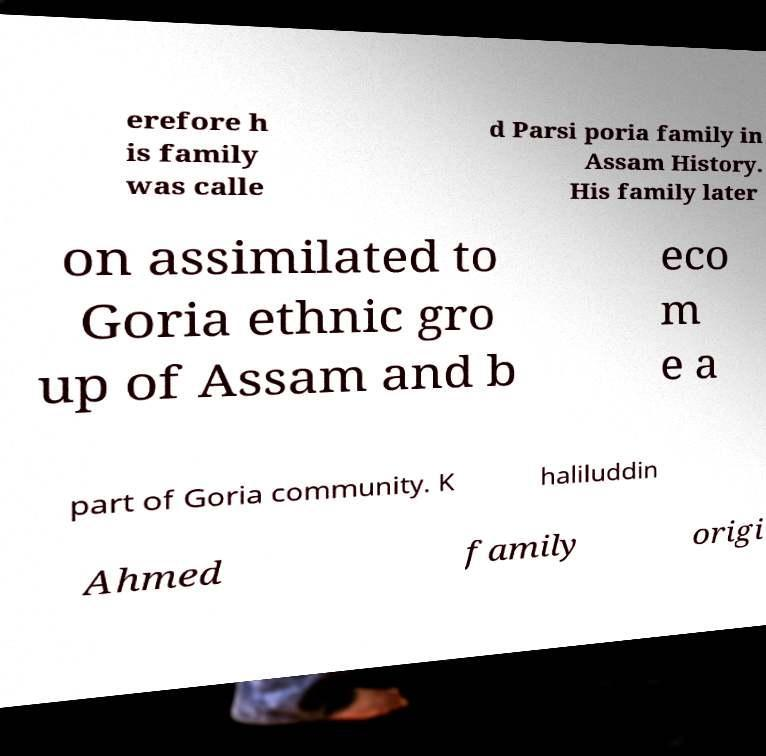Could you extract and type out the text from this image? erefore h is family was calle d Parsi poria family in Assam History. His family later on assimilated to Goria ethnic gro up of Assam and b eco m e a part of Goria community. K haliluddin Ahmed family origi 